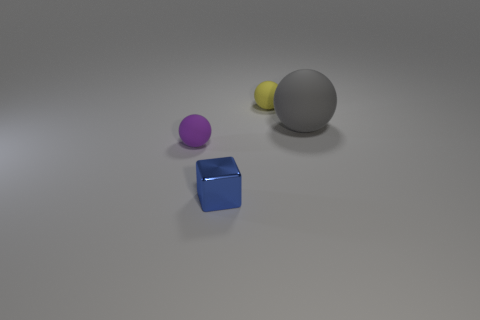Looking at their shadows, what can you infer about the light source in this scene? The shadows are relatively soft-edged and spread out on the surface, which indicates that the light source is not extremely close to the objects. The angle and positioning of the shadows suggest a single light source located above and to the right of the objects, casting shadows diagonally towards the lower left. 